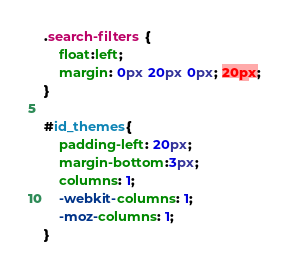Convert code to text. <code><loc_0><loc_0><loc_500><loc_500><_CSS_>.search-filters {
	float:left;
	margin: 0px 20px 0px; 20px;
}

#id_themes{
	padding-left: 20px;
	margin-bottom:3px;
	columns: 1;
	-webkit-columns: 1;
	-moz-columns: 1;
}</code> 